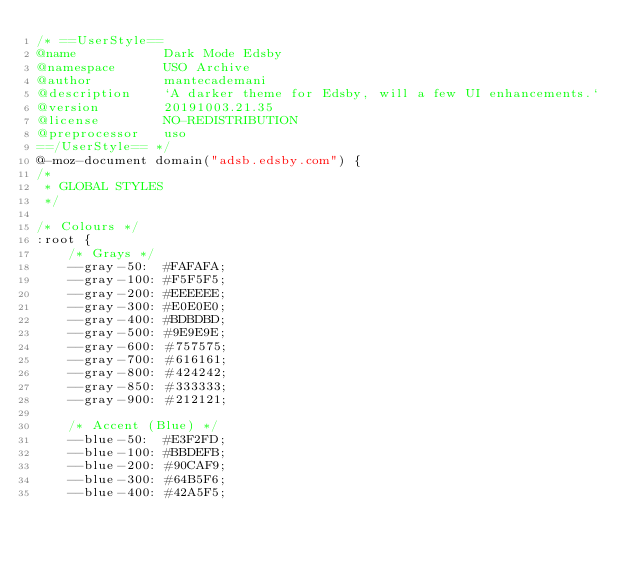Convert code to text. <code><loc_0><loc_0><loc_500><loc_500><_CSS_>/* ==UserStyle==
@name           Dark Mode Edsby
@namespace      USO Archive
@author         mantecademani
@description    `A darker theme for Edsby, will a few UI enhancements.`
@version        20191003.21.35
@license        NO-REDISTRIBUTION
@preprocessor   uso
==/UserStyle== */
@-moz-document domain("adsb.edsby.com") {
/*
 * GLOBAL STYLES
 */

/* Colours */
:root {
    /* Grays */
    --gray-50:  #FAFAFA;
    --gray-100: #F5F5F5;
    --gray-200: #EEEEEE;
    --gray-300: #E0E0E0;
    --gray-400: #BDBDBD;
    --gray-500: #9E9E9E;
    --gray-600: #757575;
    --gray-700: #616161;
    --gray-800: #424242;
    --gray-850: #333333;
    --gray-900: #212121;
    
    /* Accent (Blue) */
    --blue-50:  #E3F2FD;
    --blue-100: #BBDEFB;
    --blue-200: #90CAF9;
    --blue-300: #64B5F6;
    --blue-400: #42A5F5;</code> 